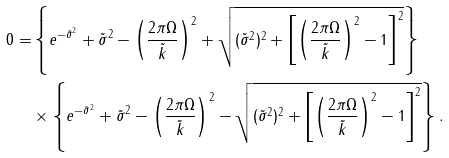<formula> <loc_0><loc_0><loc_500><loc_500>0 = & \left \{ e ^ { - \tilde { \sigma } ^ { 2 } } + \tilde { \sigma } ^ { 2 } - \left ( \frac { 2 \pi \Omega } { \tilde { k } } \right ) ^ { 2 } + \sqrt { ( \tilde { \sigma } ^ { 2 } ) ^ { 2 } + \left [ \left ( \frac { 2 \pi \Omega } { \tilde { k } } \right ) ^ { 2 } - 1 \right ] ^ { 2 } } \right \} \\ & \times \left \{ e ^ { - \tilde { \sigma } ^ { 2 } } + \tilde { \sigma } ^ { 2 } - \left ( \frac { 2 \pi \Omega } { \tilde { k } } \right ) ^ { 2 } - \sqrt { ( \tilde { \sigma } ^ { 2 } ) ^ { 2 } + \left [ \left ( \frac { 2 \pi \Omega } { \tilde { k } } \right ) ^ { 2 } - 1 \right ] ^ { 2 } } \right \} .</formula> 